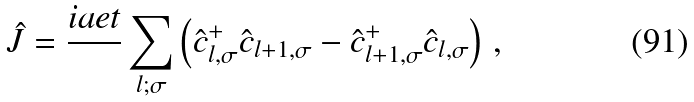Convert formula to latex. <formula><loc_0><loc_0><loc_500><loc_500>\hat { J } = \frac { i a e t } { } \sum _ { l ; \sigma } \left ( \hat { c } _ { l , \sigma } ^ { + } \hat { c } _ { l + 1 , \sigma } - \hat { c } _ { l + 1 , \sigma } ^ { + } \hat { c } _ { l , \sigma } \right ) \, ,</formula> 